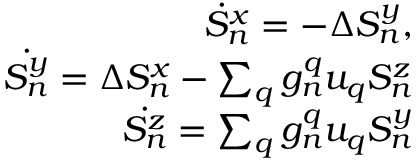Convert formula to latex. <formula><loc_0><loc_0><loc_500><loc_500>\begin{array} { r } { \dot { S } _ { n } ^ { x } = - \Delta S _ { n } ^ { y } , } \\ { \dot { S _ { n } ^ { y } } = \Delta S _ { n } ^ { x } - \sum _ { q } g _ { n } ^ { q } u _ { q } S _ { n } ^ { z } } \\ { \dot { S _ { n } ^ { z } } = \sum _ { q } g _ { n } ^ { q } u _ { q } S _ { n } ^ { y } } \end{array}</formula> 